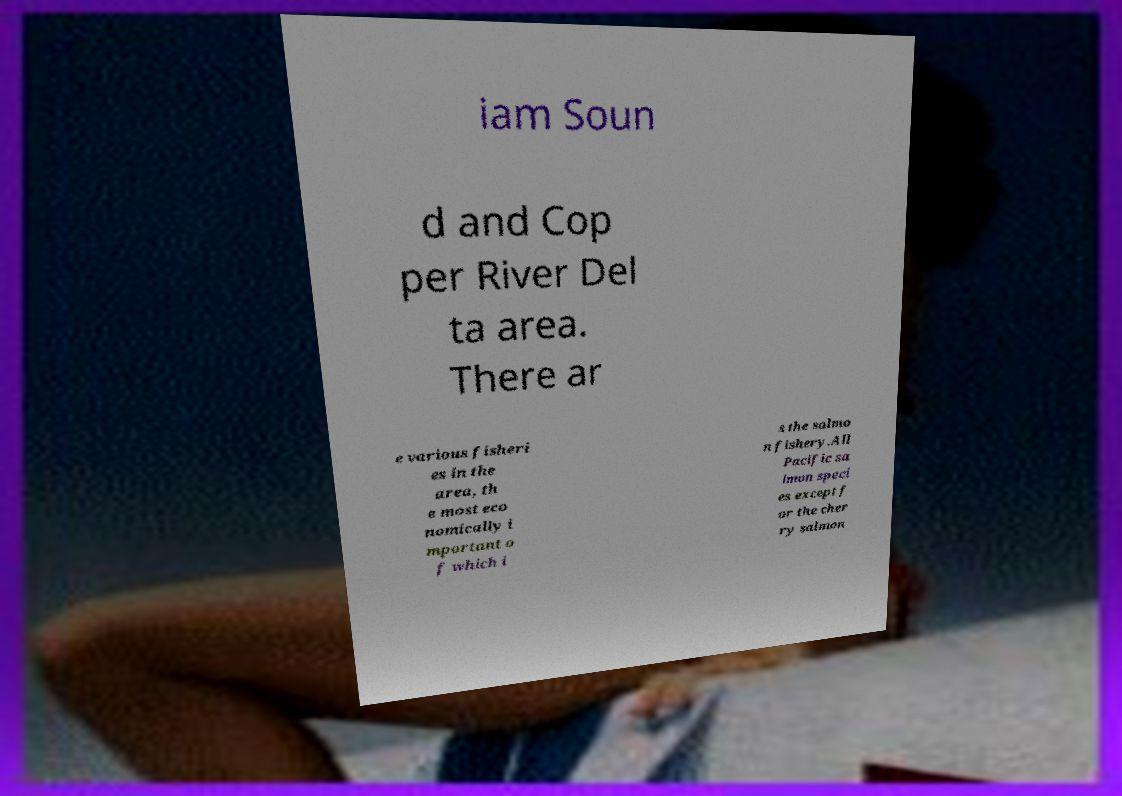Can you accurately transcribe the text from the provided image for me? iam Soun d and Cop per River Del ta area. There ar e various fisheri es in the area, th e most eco nomically i mportant o f which i s the salmo n fishery.All Pacific sa lmon speci es except f or the cher ry salmon 